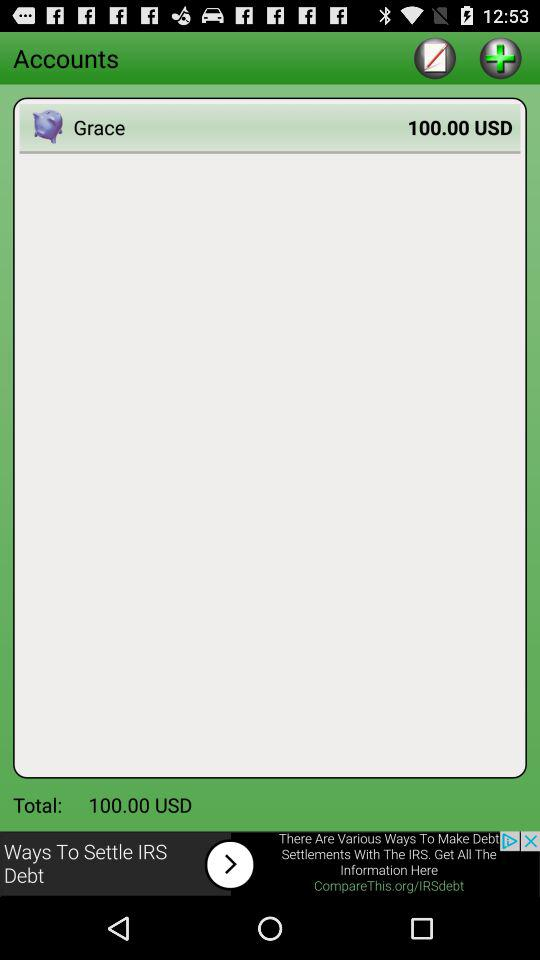How many USD in total are there in Grace's account? There are 100 USD in Grace's account. 